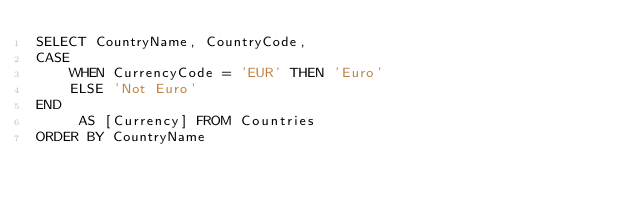Convert code to text. <code><loc_0><loc_0><loc_500><loc_500><_SQL_>SELECT CountryName, CountryCode, 
CASE
	WHEN CurrencyCode = 'EUR' THEN 'Euro'
	ELSE 'Not Euro'
END
	 AS [Currency] FROM Countries
ORDER BY CountryName

</code> 